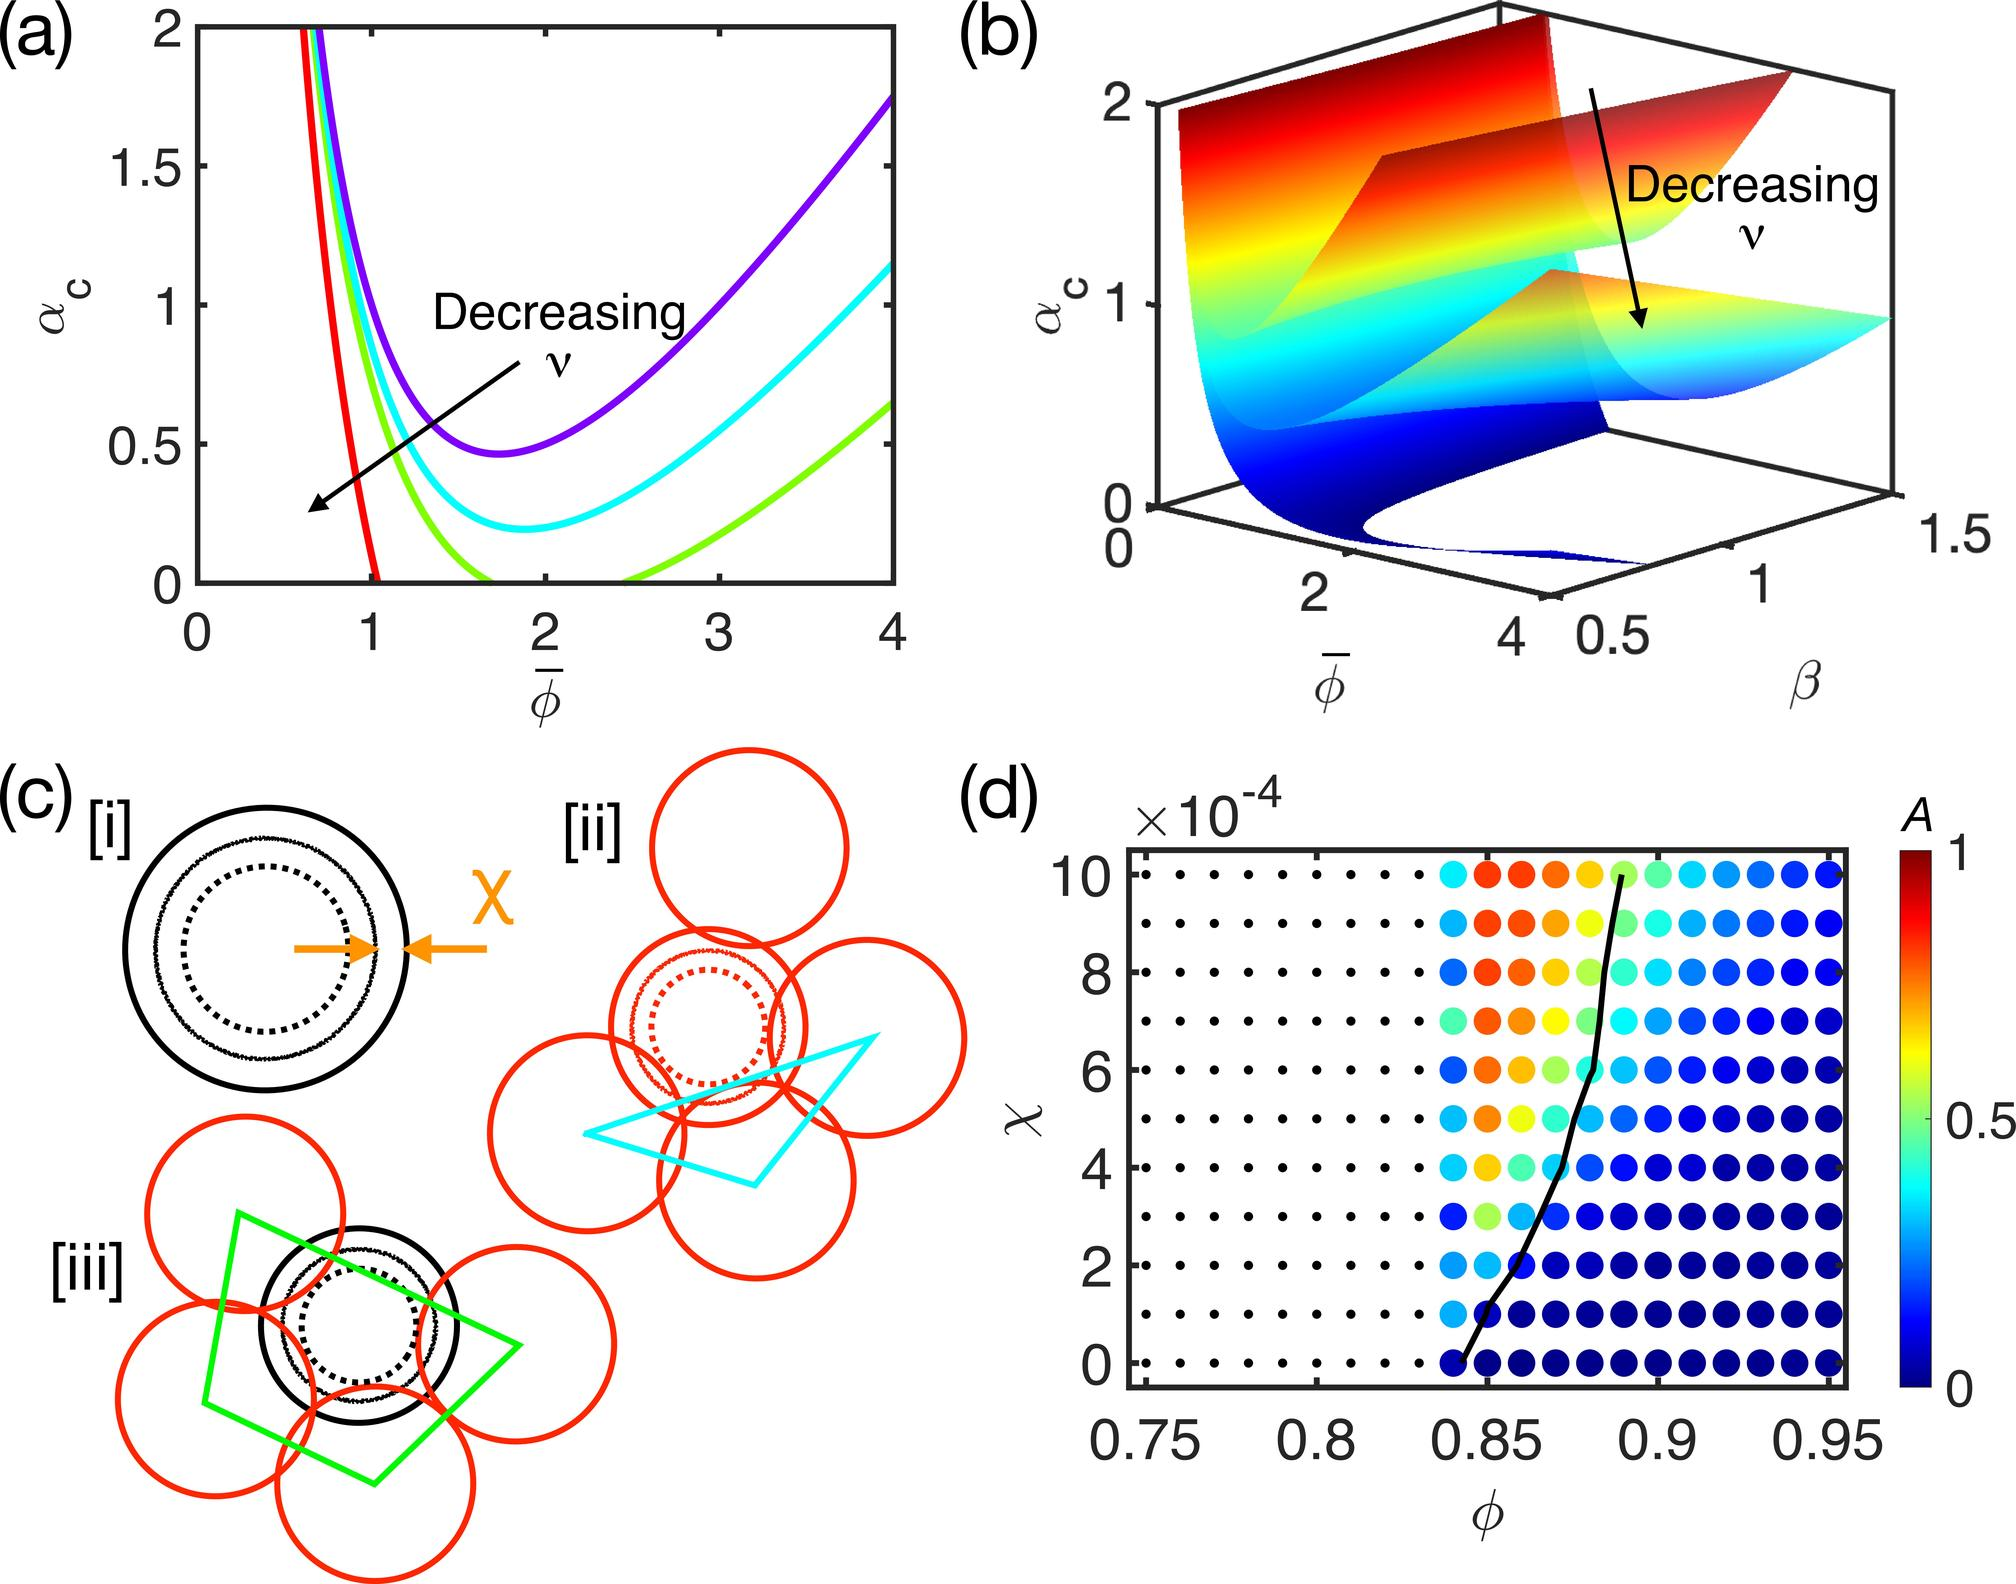What trend is indicated by the color gradient in relation to the variable \(\phi\)? A. A is proportional to \(\phi\) B. A is inversely proportional to \(\phi\) C. A has no correlation with \(\phi\) D. A has a complex relationship with \(\phi\), showing regions of both direct and inverse proportionality The color gradient in the graph changes consistently across the spectrum from a cool to warm as the variable \(\phi\) increases. This suggests that the variable A, indicated by the heat map, does not show a linear or simple relationship. Instead, A appears to increase in certain ranges of \(\phi\) (as shown by warmer colors at lower \(\phi\) values) and decrease in others (indicated by cooler colors at higher \(\phi\) values). The distribution of colors suggests multiple turning points, implying that A's relationship with \(\phi\) includes regions of both positive and negative correlation. This complexity hints at underlying dynamics that are more involved than a simple direct or inverse relationship. The conclusion is thus that option D is the correct interpretation, highlighting the non-linear and multifaceted interaction between A and \(\phi\). 